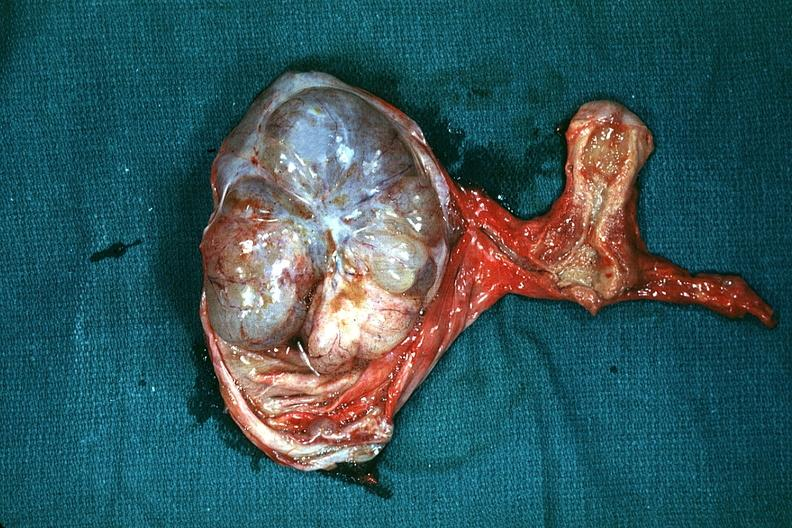s the excellent uterus in picture and thus illustrates the very large size of the ovarian tumor?
Answer the question using a single word or phrase. Yes 